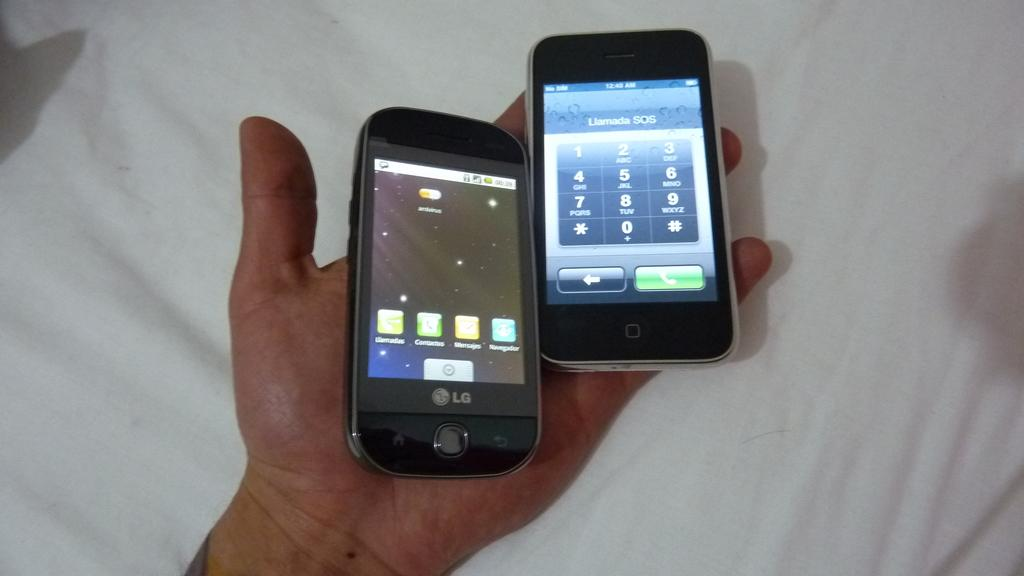Provide a one-sentence caption for the provided image. two cellphones in one hand, one an LG and the other an iphone. 